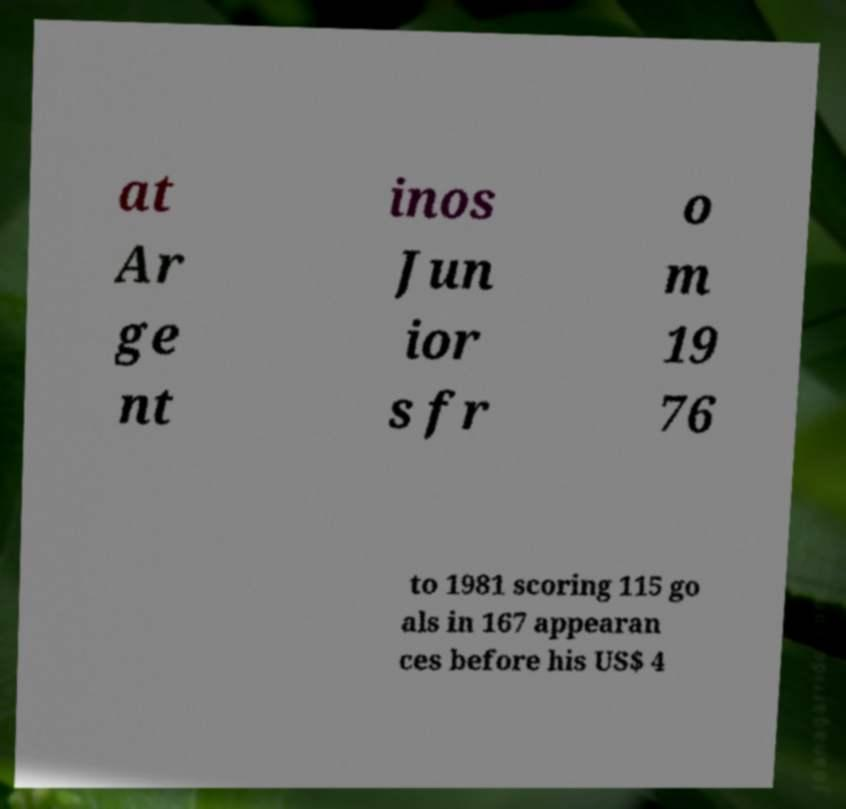Can you accurately transcribe the text from the provided image for me? at Ar ge nt inos Jun ior s fr o m 19 76 to 1981 scoring 115 go als in 167 appearan ces before his US$ 4 